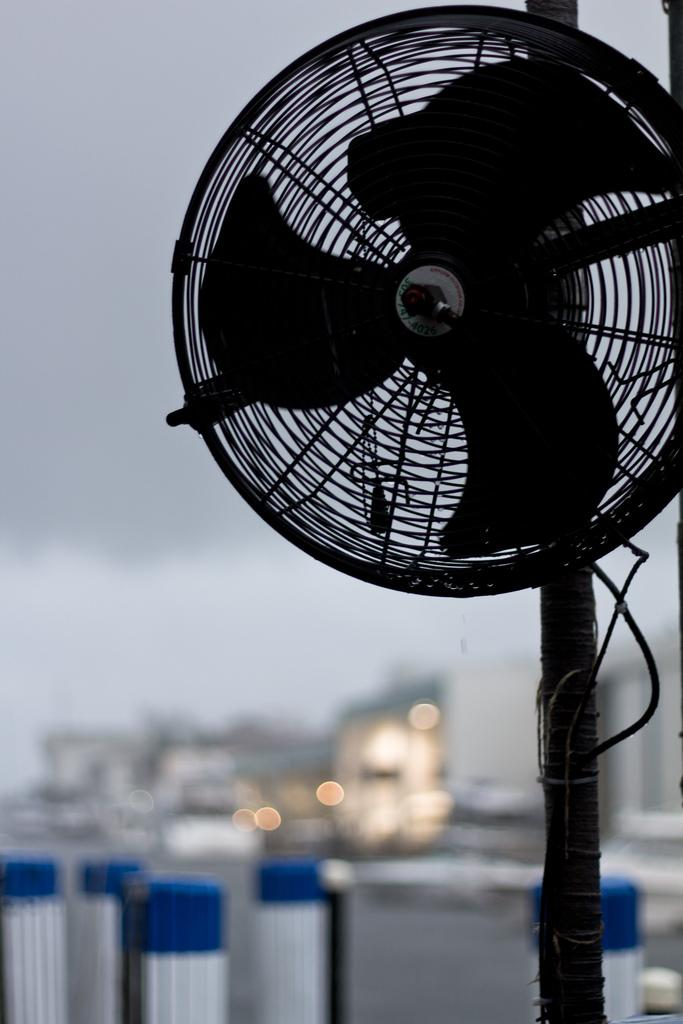What object can be seen in the image that is used for cooling? There is a fan in the image. What type of structures can be seen in the background of the image? There are buildings in the background of the image. What is visible at the top of the image? The sky is visible at the top of the image. Can you tell me where the father and cub are located in the image? There is no father or cub present in the image. 